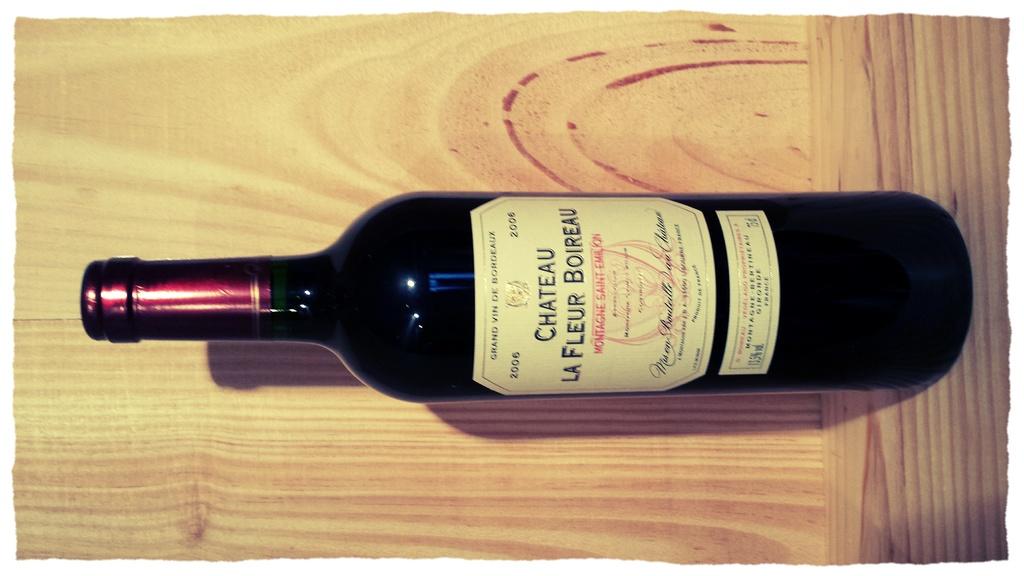What type of wine is this?
Your answer should be compact. Chateau la fleur boireau. What year was this wine made?
Your response must be concise. 2006. 